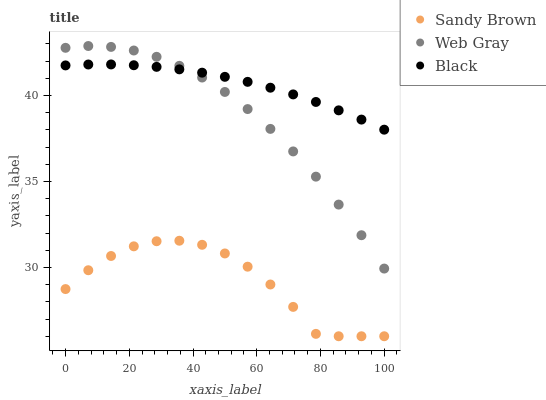Does Sandy Brown have the minimum area under the curve?
Answer yes or no. Yes. Does Black have the maximum area under the curve?
Answer yes or no. Yes. Does Web Gray have the minimum area under the curve?
Answer yes or no. No. Does Web Gray have the maximum area under the curve?
Answer yes or no. No. Is Black the smoothest?
Answer yes or no. Yes. Is Sandy Brown the roughest?
Answer yes or no. Yes. Is Web Gray the smoothest?
Answer yes or no. No. Is Web Gray the roughest?
Answer yes or no. No. Does Sandy Brown have the lowest value?
Answer yes or no. Yes. Does Web Gray have the lowest value?
Answer yes or no. No. Does Web Gray have the highest value?
Answer yes or no. Yes. Does Sandy Brown have the highest value?
Answer yes or no. No. Is Sandy Brown less than Black?
Answer yes or no. Yes. Is Black greater than Sandy Brown?
Answer yes or no. Yes. Does Web Gray intersect Black?
Answer yes or no. Yes. Is Web Gray less than Black?
Answer yes or no. No. Is Web Gray greater than Black?
Answer yes or no. No. Does Sandy Brown intersect Black?
Answer yes or no. No. 